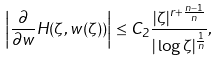Convert formula to latex. <formula><loc_0><loc_0><loc_500><loc_500>\left | \frac { \partial } { \partial w } H ( \zeta , w ( \zeta ) ) \right | \leq C _ { 2 } \frac { | \zeta | ^ { r + \frac { n - 1 } { n } } } { | \log \zeta | ^ { \frac { 1 } { n } } } ,</formula> 